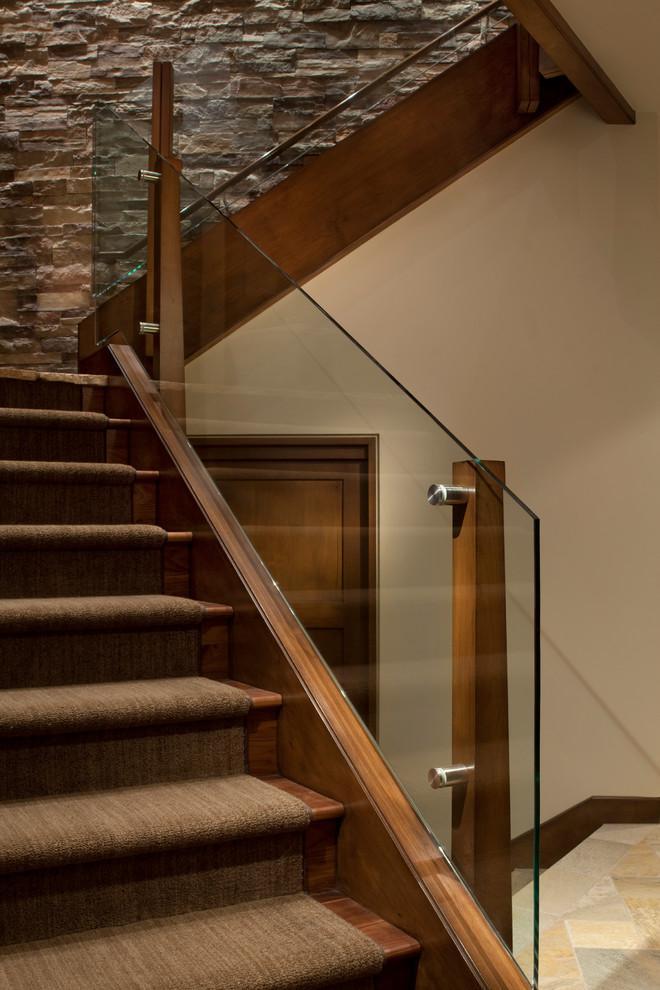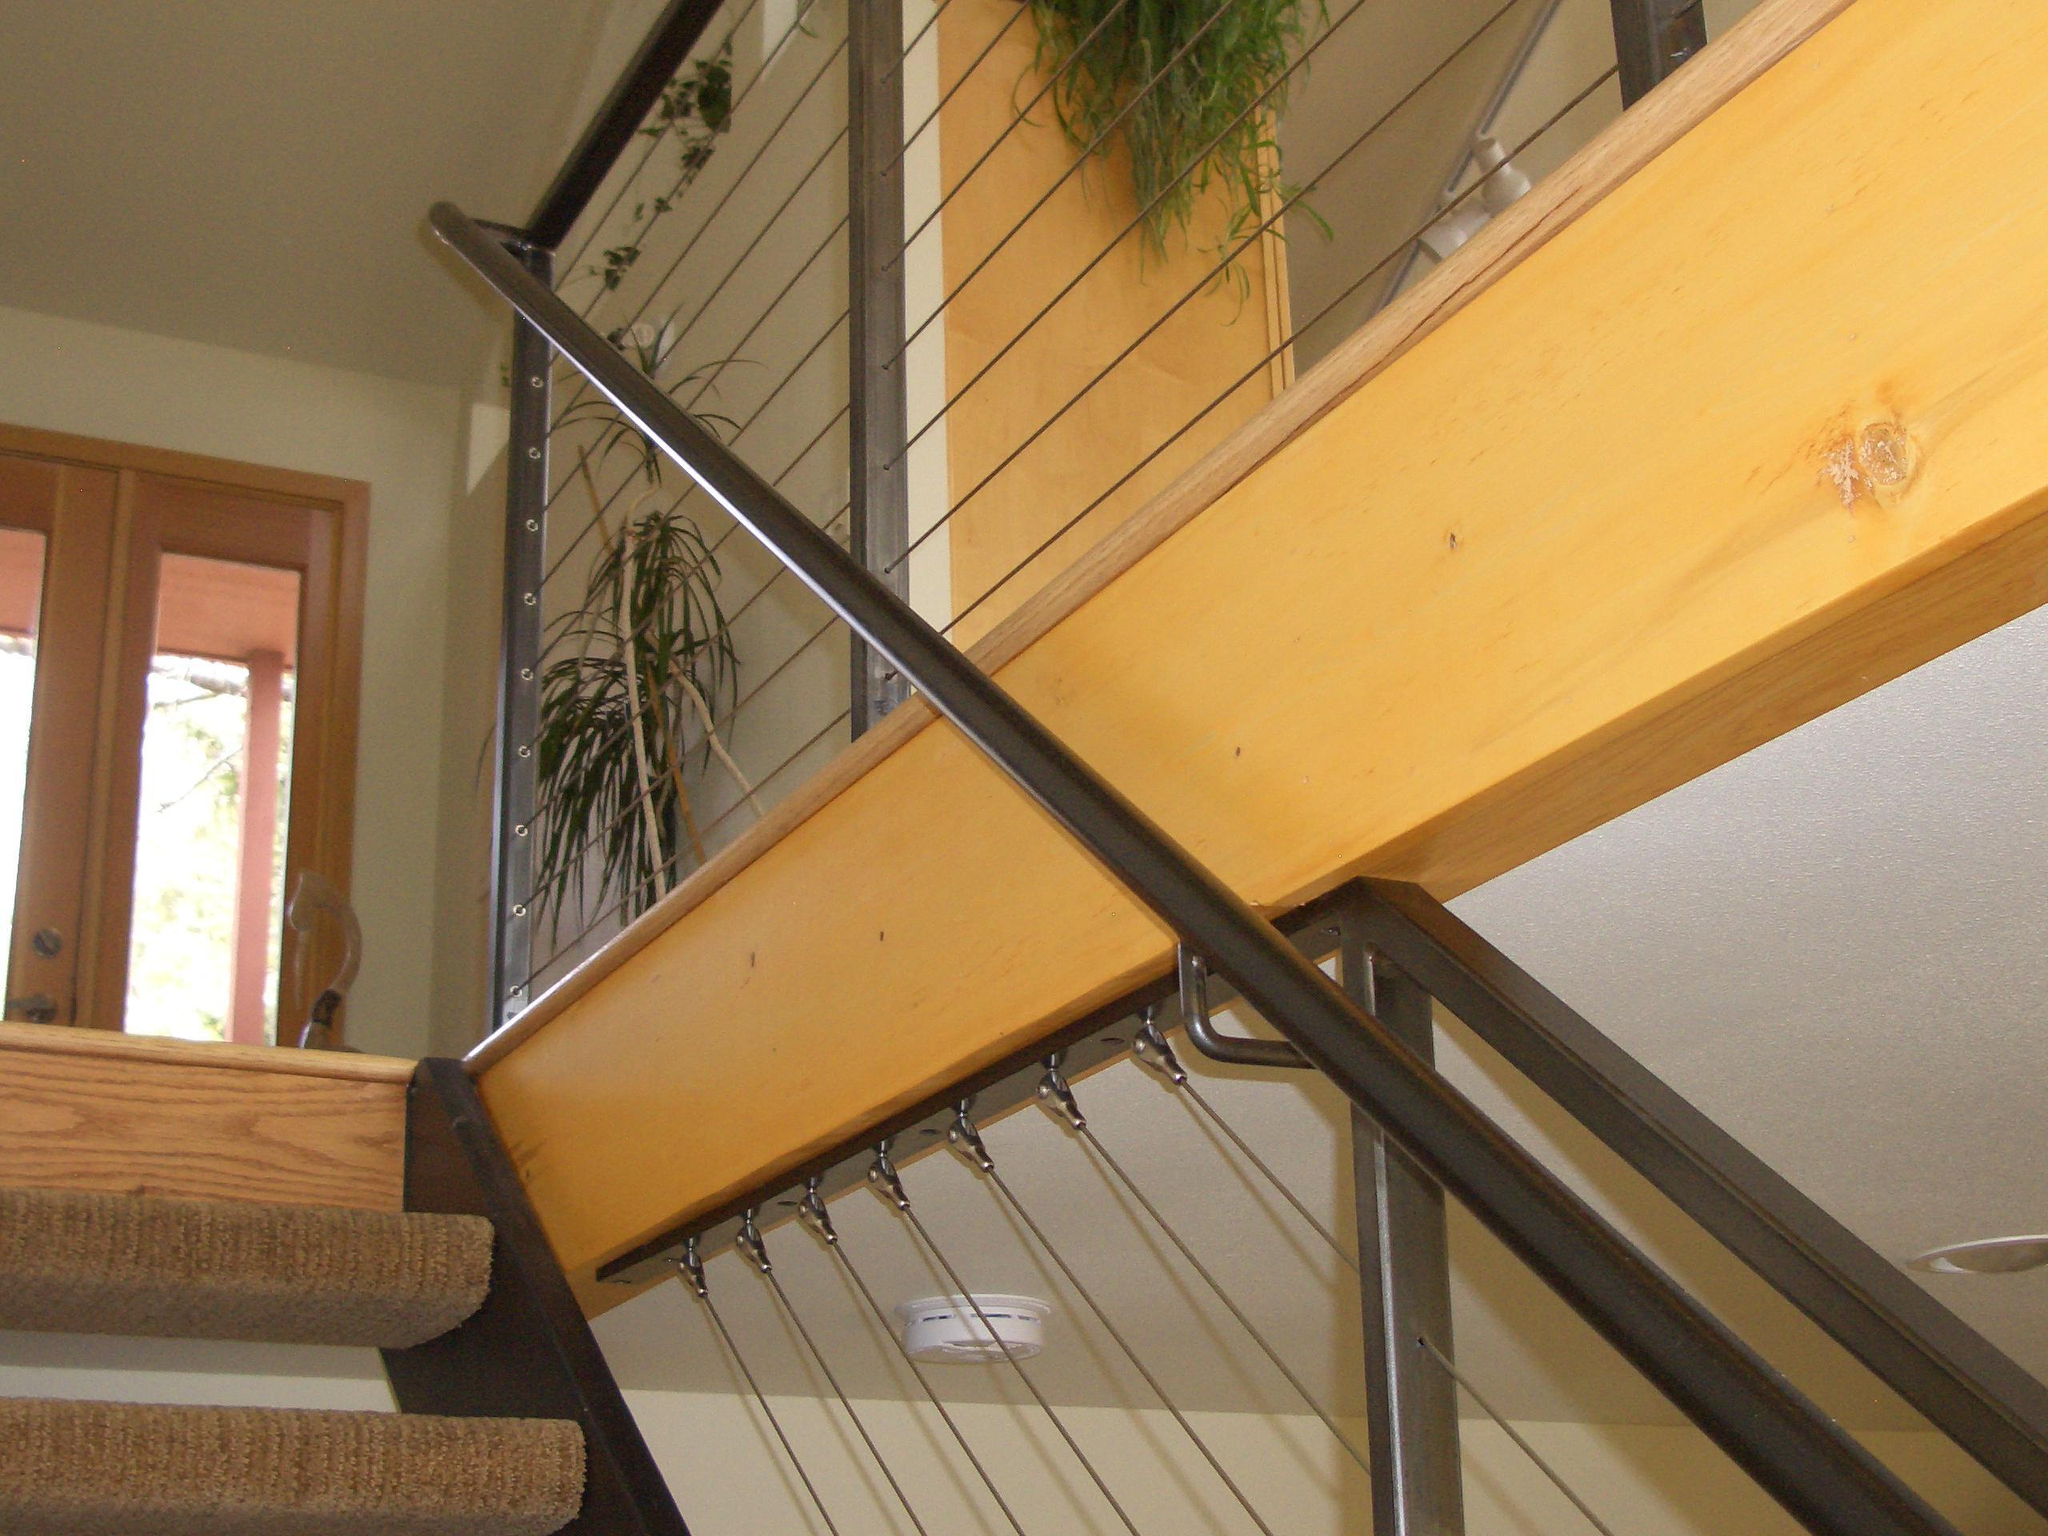The first image is the image on the left, the second image is the image on the right. Considering the images on both sides, is "One image shows a diagonal 'floating' staircase in front of a brick-like wall and over an open stairwell." valid? Answer yes or no. No. The first image is the image on the left, the second image is the image on the right. Examine the images to the left and right. Is the description "The right image contains a staircase with a black handrail." accurate? Answer yes or no. Yes. 